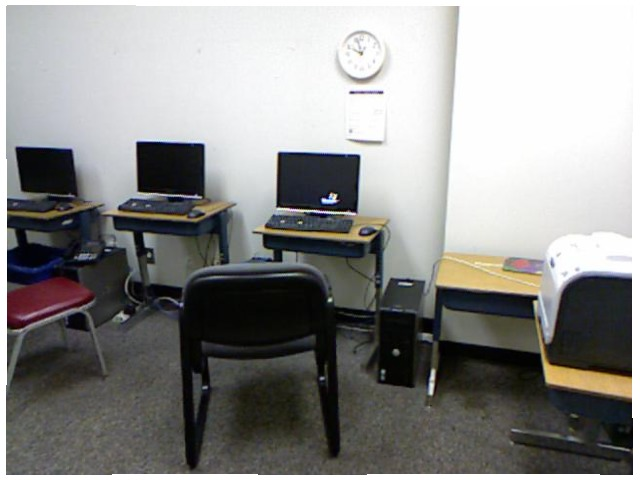<image>
Is there a clock above the computer? Yes. The clock is positioned above the computer in the vertical space, higher up in the scene. Is there a computer monitor on the table? No. The computer monitor is not positioned on the table. They may be near each other, but the computer monitor is not supported by or resting on top of the table. 